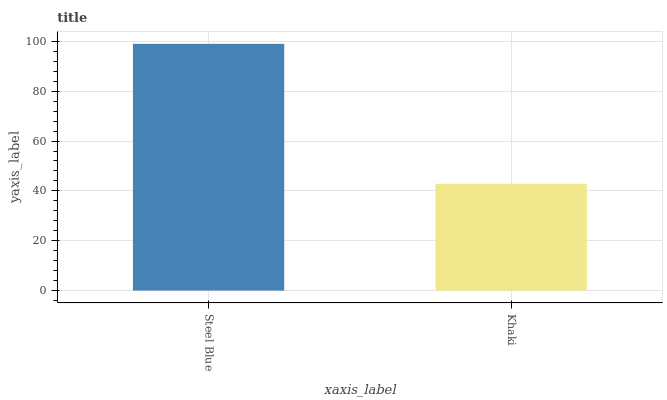Is Khaki the minimum?
Answer yes or no. Yes. Is Steel Blue the maximum?
Answer yes or no. Yes. Is Khaki the maximum?
Answer yes or no. No. Is Steel Blue greater than Khaki?
Answer yes or no. Yes. Is Khaki less than Steel Blue?
Answer yes or no. Yes. Is Khaki greater than Steel Blue?
Answer yes or no. No. Is Steel Blue less than Khaki?
Answer yes or no. No. Is Steel Blue the high median?
Answer yes or no. Yes. Is Khaki the low median?
Answer yes or no. Yes. Is Khaki the high median?
Answer yes or no. No. Is Steel Blue the low median?
Answer yes or no. No. 